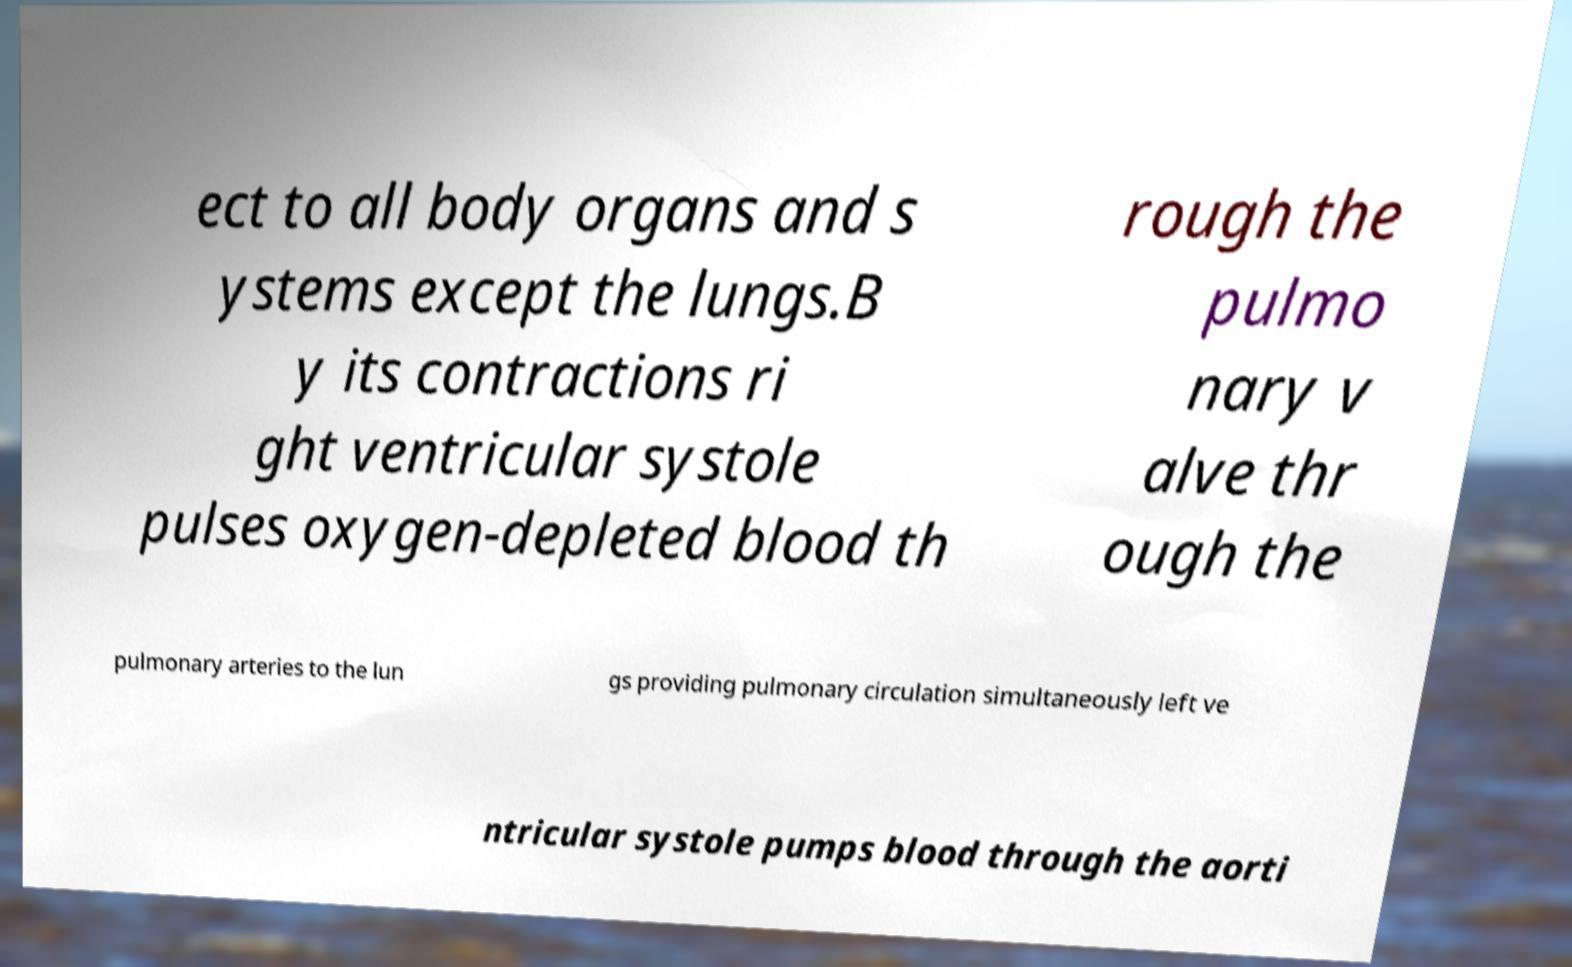Can you read and provide the text displayed in the image?This photo seems to have some interesting text. Can you extract and type it out for me? ect to all body organs and s ystems except the lungs.B y its contractions ri ght ventricular systole pulses oxygen-depleted blood th rough the pulmo nary v alve thr ough the pulmonary arteries to the lun gs providing pulmonary circulation simultaneously left ve ntricular systole pumps blood through the aorti 